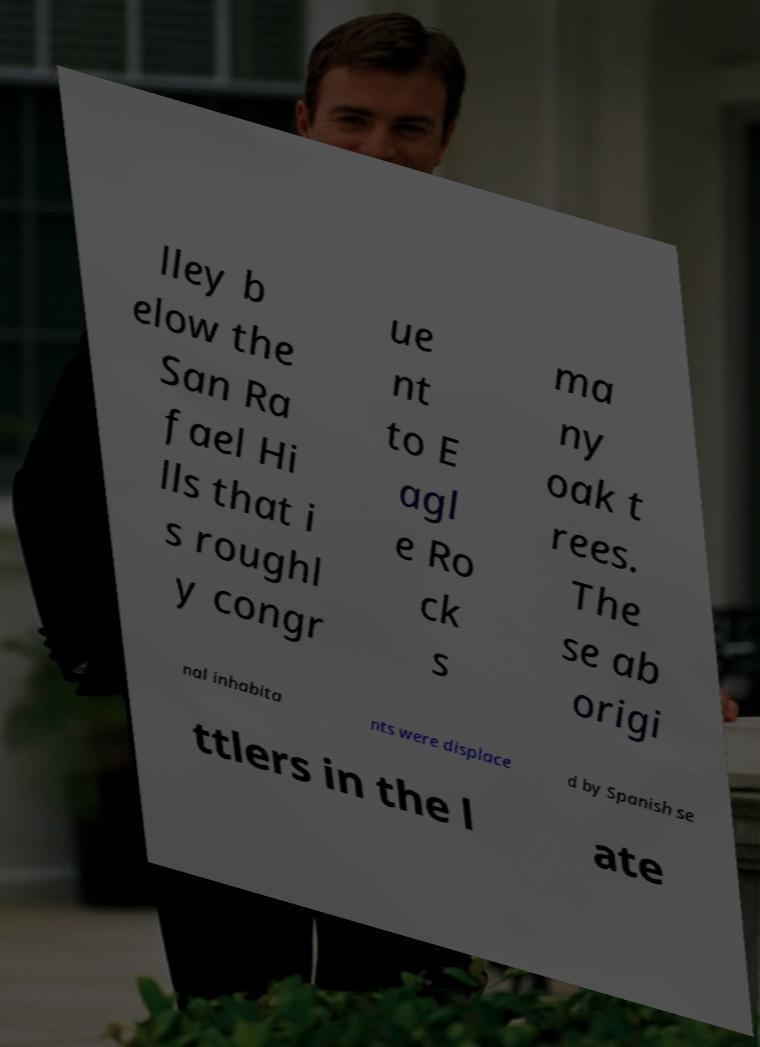Can you read and provide the text displayed in the image?This photo seems to have some interesting text. Can you extract and type it out for me? lley b elow the San Ra fael Hi lls that i s roughl y congr ue nt to E agl e Ro ck s ma ny oak t rees. The se ab origi nal inhabita nts were displace d by Spanish se ttlers in the l ate 